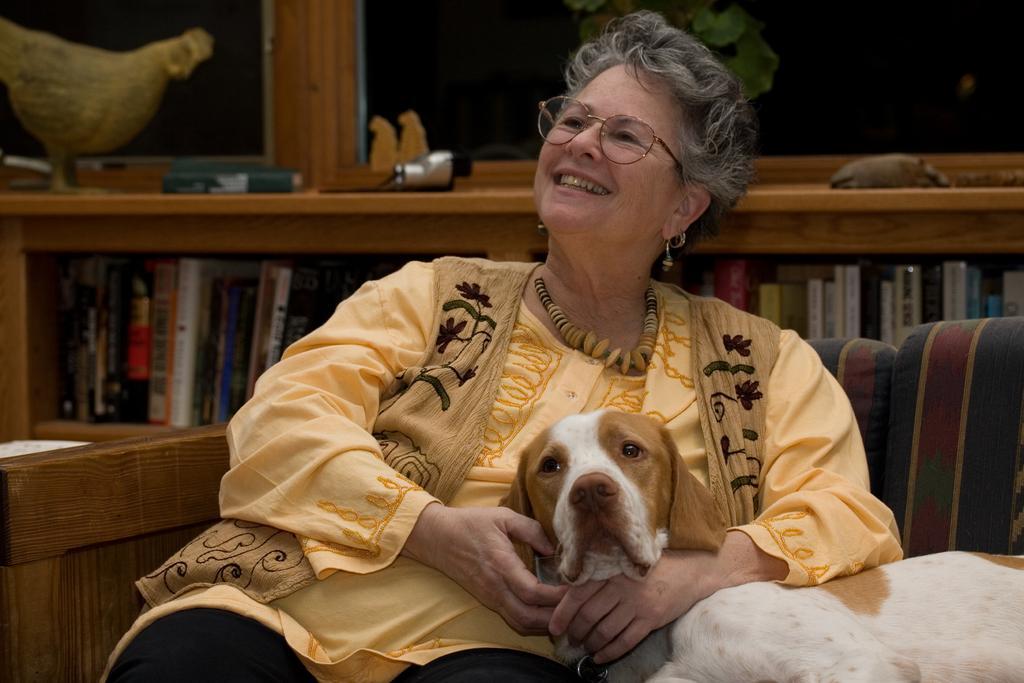How would you summarize this image in a sentence or two? There is a woman sitting on wooden sofa. She is holding a dog. The dog looks pretty good. This is a bookshelf. There is a hen at the left corner. 